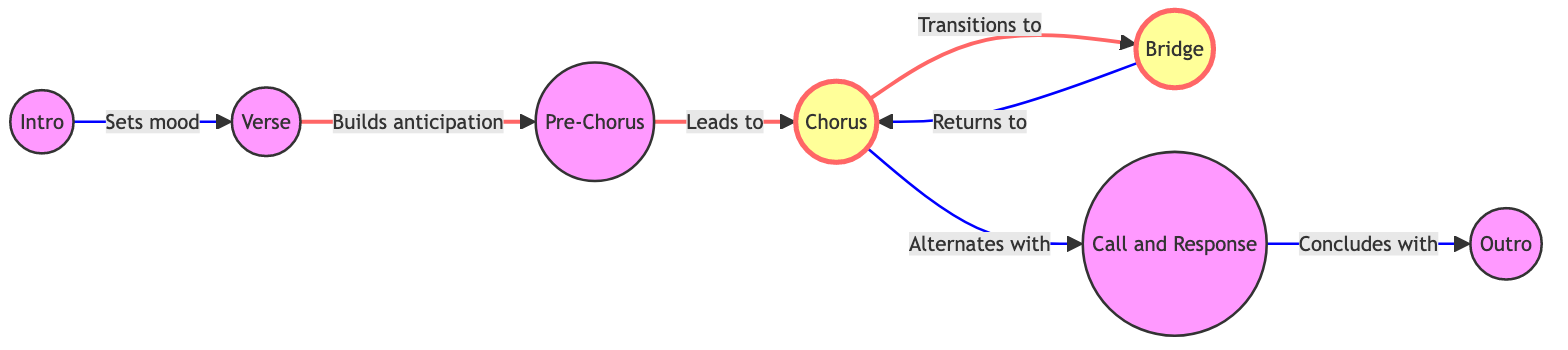What is the first section of the song according to the diagram? The diagram indicates that the "Intro" is the starting section of the song, as it is the first node in the flow and points toward the next section "Verse."
Answer: Intro How many sections are present in the song structure shown in the diagram? There are a total of 7 sections represented as nodes in the diagram: Intro, Verse, Pre-Chorus, Chorus, Bridge, Call and Response, and Outro.
Answer: 7 Which section follows the "Verse" in the flow? Based on the connections in the diagram, "Pre-Chorus" is the next section after "Verse," as indicated by the directed edge connecting them.
Answer: Pre-Chorus What section is highlighted in the diagram? The sections that are highlighted in the diagram are "Chorus" and "Bridge," as they have a different visual style applied to them compared to other sections.
Answer: Chorus and Bridge Which sections are connected in the diagram between "Chorus" and "Bridge"? The diagram shows that "Chorus" connects to "Bridge" first, and then it leads back to "Chorus," indicating a circular relationship between these two sections.
Answer: Bridge How does the "Call and Response" lead to the "Outro"? According to the diagram, the "Call and Response" section directs flow towards the "Outro," showing it as a concluding part that follows that interaction.
Answer: Outro What role does "Pre-Chorus" play in the flow of the song? The "Pre-Chorus" serves as a transitional section between "Verse" and "Chorus," designed to build anticipation for the chorus, as noted by the labels on the connecting edges.
Answer: Build anticipation How does "Chorus" relate to "Call and Response"? In the diagram, "Chorus" alternates with "Call and Response," indicating they share a relationship where both sections play off each other within the flow of the song.
Answer: Alternates with What is the final section of the song as per the diagram? The diagram indicates that the "Outro" represents the last section in the flow, following the "Call and Response" which indicates a conclusion to the song structure.
Answer: Outro 